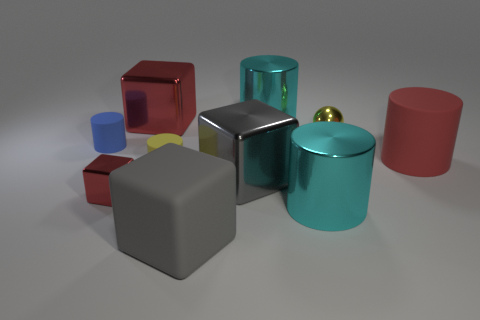Does the small metal cube have the same color as the big rubber cylinder?
Offer a very short reply. Yes. There is a cyan object that is in front of the yellow cylinder; is it the same size as the small yellow cylinder?
Offer a terse response. No. What number of things are either small objects or yellow matte cylinders?
Provide a succinct answer. 4. What is the shape of the big thing that is the same color as the big rubber cube?
Provide a short and direct response. Cube. There is a metallic object that is both on the left side of the gray shiny object and in front of the red matte cylinder; how big is it?
Offer a terse response. Small. What number of tiny matte cylinders are there?
Your response must be concise. 2. What number of balls are yellow matte objects or blue matte objects?
Provide a short and direct response. 0. There is a cyan metal thing on the right side of the cyan metal cylinder behind the big red metal object; how many yellow metal spheres are left of it?
Keep it short and to the point. 0. What color is the block that is the same size as the blue matte thing?
Provide a succinct answer. Red. How many other objects are the same color as the sphere?
Your response must be concise. 1. 